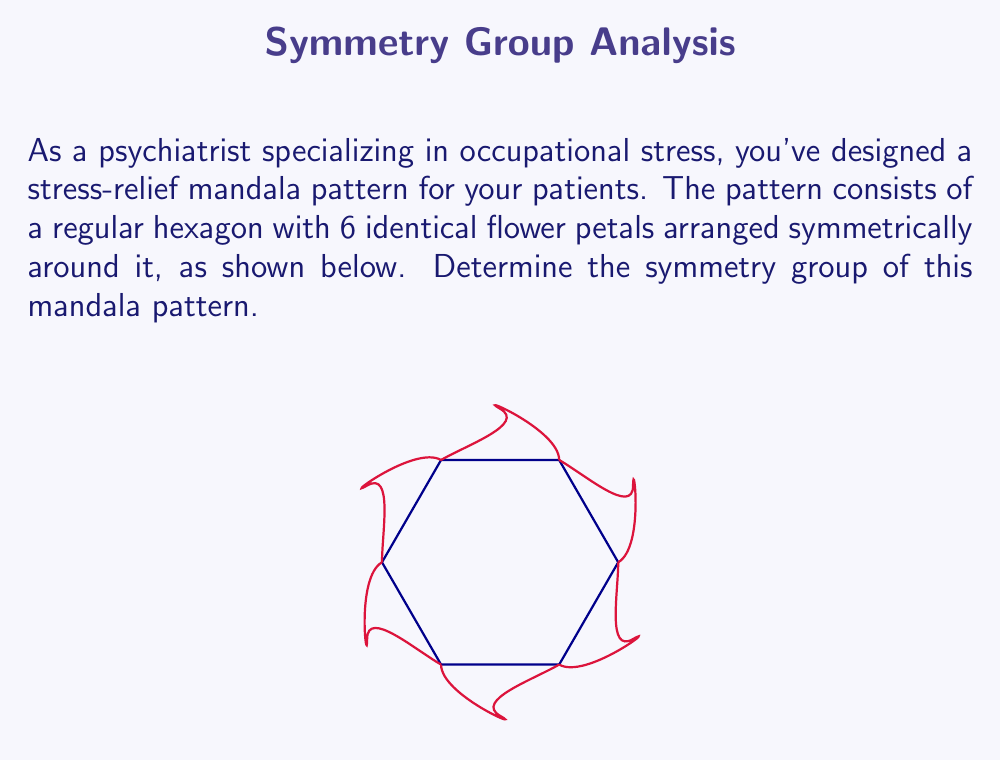Can you answer this question? To determine the symmetry group of this mandala pattern, we need to identify all the symmetry operations that leave the pattern unchanged. Let's approach this step-by-step:

1. Rotational symmetries:
   - The pattern has 6-fold rotational symmetry, meaning it remains unchanged when rotated by multiples of 60°.
   - The rotations are: 0°, 60°, 120°, 180°, 240°, 300°

2. Reflection symmetries:
   - There are 6 lines of reflection symmetry:
     - 3 passing through opposite vertices of the hexagon
     - 3 passing through the midpoints of opposite sides of the hexagon

3. Identity transformation:
   - The identity transformation (doing nothing) is always a symmetry.

4. Counting the symmetries:
   - 6 rotations (including identity)
   - 6 reflections
   - Total: 12 symmetries

5. Identifying the group:
   - This group of 12 symmetries is known as the dihedral group of order 12, denoted as $D_6$ or $D_{12}$.
   - The general formula for the order of a dihedral group is $2n$, where $n$ is the number of vertices in the regular polygon (in this case, $n=6$).

6. Group structure:
   - The group can be generated by two elements:
     $r$: rotation by 60°
     $s$: reflection across any axis
   - These generators satisfy the relations:
     $r^6 = e$ (identity)
     $s^2 = e$
     $srs = r^{-1}$

Therefore, the symmetry group of this mandala pattern is the dihedral group $D_6$ (or $D_{12}$), which has 12 elements and is non-abelian.
Answer: $D_6$ (or $D_{12}$) 